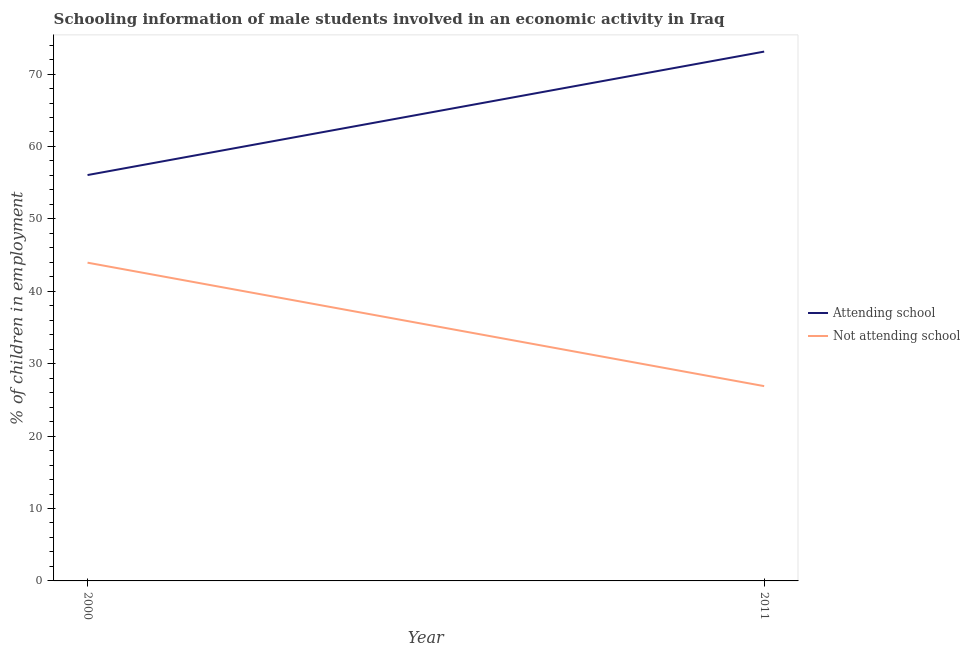What is the percentage of employed males who are attending school in 2011?
Your answer should be very brief. 73.1. Across all years, what is the maximum percentage of employed males who are not attending school?
Provide a short and direct response. 43.95. Across all years, what is the minimum percentage of employed males who are attending school?
Provide a short and direct response. 56.05. In which year was the percentage of employed males who are not attending school minimum?
Keep it short and to the point. 2011. What is the total percentage of employed males who are not attending school in the graph?
Provide a short and direct response. 70.85. What is the difference between the percentage of employed males who are not attending school in 2000 and that in 2011?
Ensure brevity in your answer.  17.05. What is the difference between the percentage of employed males who are not attending school in 2011 and the percentage of employed males who are attending school in 2000?
Give a very brief answer. -29.15. What is the average percentage of employed males who are attending school per year?
Your response must be concise. 64.58. In the year 2000, what is the difference between the percentage of employed males who are attending school and percentage of employed males who are not attending school?
Make the answer very short. 12.1. In how many years, is the percentage of employed males who are attending school greater than 36 %?
Offer a very short reply. 2. What is the ratio of the percentage of employed males who are not attending school in 2000 to that in 2011?
Your answer should be compact. 1.63. Is the percentage of employed males who are attending school in 2000 less than that in 2011?
Make the answer very short. Yes. In how many years, is the percentage of employed males who are attending school greater than the average percentage of employed males who are attending school taken over all years?
Your answer should be very brief. 1. Is the percentage of employed males who are attending school strictly greater than the percentage of employed males who are not attending school over the years?
Offer a very short reply. Yes. Is the percentage of employed males who are not attending school strictly less than the percentage of employed males who are attending school over the years?
Offer a terse response. Yes. What is the difference between two consecutive major ticks on the Y-axis?
Give a very brief answer. 10. Are the values on the major ticks of Y-axis written in scientific E-notation?
Provide a short and direct response. No. Does the graph contain grids?
Give a very brief answer. No. Where does the legend appear in the graph?
Provide a short and direct response. Center right. How many legend labels are there?
Ensure brevity in your answer.  2. What is the title of the graph?
Provide a succinct answer. Schooling information of male students involved in an economic activity in Iraq. Does "Under five" appear as one of the legend labels in the graph?
Provide a short and direct response. No. What is the label or title of the Y-axis?
Your answer should be very brief. % of children in employment. What is the % of children in employment of Attending school in 2000?
Give a very brief answer. 56.05. What is the % of children in employment of Not attending school in 2000?
Offer a very short reply. 43.95. What is the % of children in employment of Attending school in 2011?
Keep it short and to the point. 73.1. What is the % of children in employment of Not attending school in 2011?
Give a very brief answer. 26.9. Across all years, what is the maximum % of children in employment in Attending school?
Ensure brevity in your answer.  73.1. Across all years, what is the maximum % of children in employment of Not attending school?
Provide a succinct answer. 43.95. Across all years, what is the minimum % of children in employment of Attending school?
Your answer should be compact. 56.05. Across all years, what is the minimum % of children in employment of Not attending school?
Your answer should be compact. 26.9. What is the total % of children in employment of Attending school in the graph?
Make the answer very short. 129.15. What is the total % of children in employment in Not attending school in the graph?
Make the answer very short. 70.85. What is the difference between the % of children in employment of Attending school in 2000 and that in 2011?
Your answer should be compact. -17.05. What is the difference between the % of children in employment of Not attending school in 2000 and that in 2011?
Offer a terse response. 17.05. What is the difference between the % of children in employment in Attending school in 2000 and the % of children in employment in Not attending school in 2011?
Provide a short and direct response. 29.15. What is the average % of children in employment in Attending school per year?
Offer a very short reply. 64.58. What is the average % of children in employment in Not attending school per year?
Your answer should be compact. 35.42. In the year 2000, what is the difference between the % of children in employment in Attending school and % of children in employment in Not attending school?
Offer a very short reply. 12.1. In the year 2011, what is the difference between the % of children in employment of Attending school and % of children in employment of Not attending school?
Provide a succinct answer. 46.2. What is the ratio of the % of children in employment of Attending school in 2000 to that in 2011?
Make the answer very short. 0.77. What is the ratio of the % of children in employment in Not attending school in 2000 to that in 2011?
Make the answer very short. 1.63. What is the difference between the highest and the second highest % of children in employment in Attending school?
Provide a short and direct response. 17.05. What is the difference between the highest and the second highest % of children in employment in Not attending school?
Your answer should be very brief. 17.05. What is the difference between the highest and the lowest % of children in employment in Attending school?
Provide a short and direct response. 17.05. What is the difference between the highest and the lowest % of children in employment of Not attending school?
Your response must be concise. 17.05. 